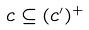Convert formula to latex. <formula><loc_0><loc_0><loc_500><loc_500>c \subseteq ( c ^ { \prime } ) ^ { + }</formula> 